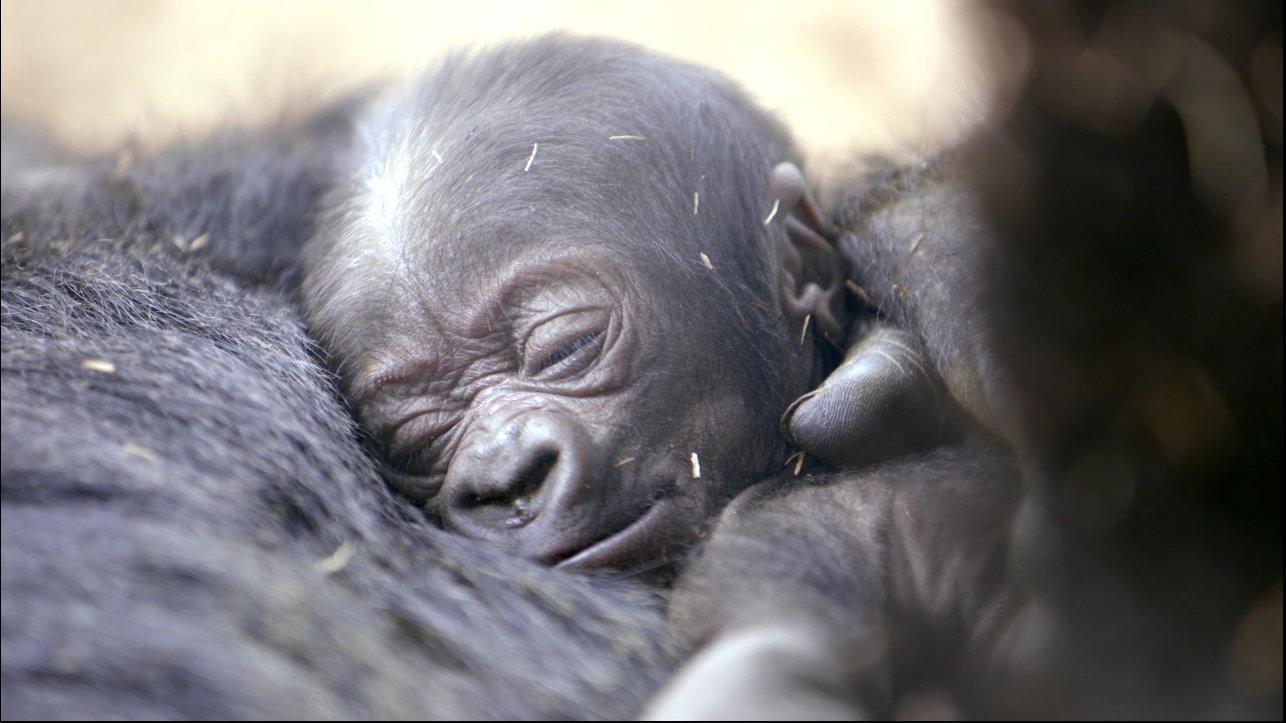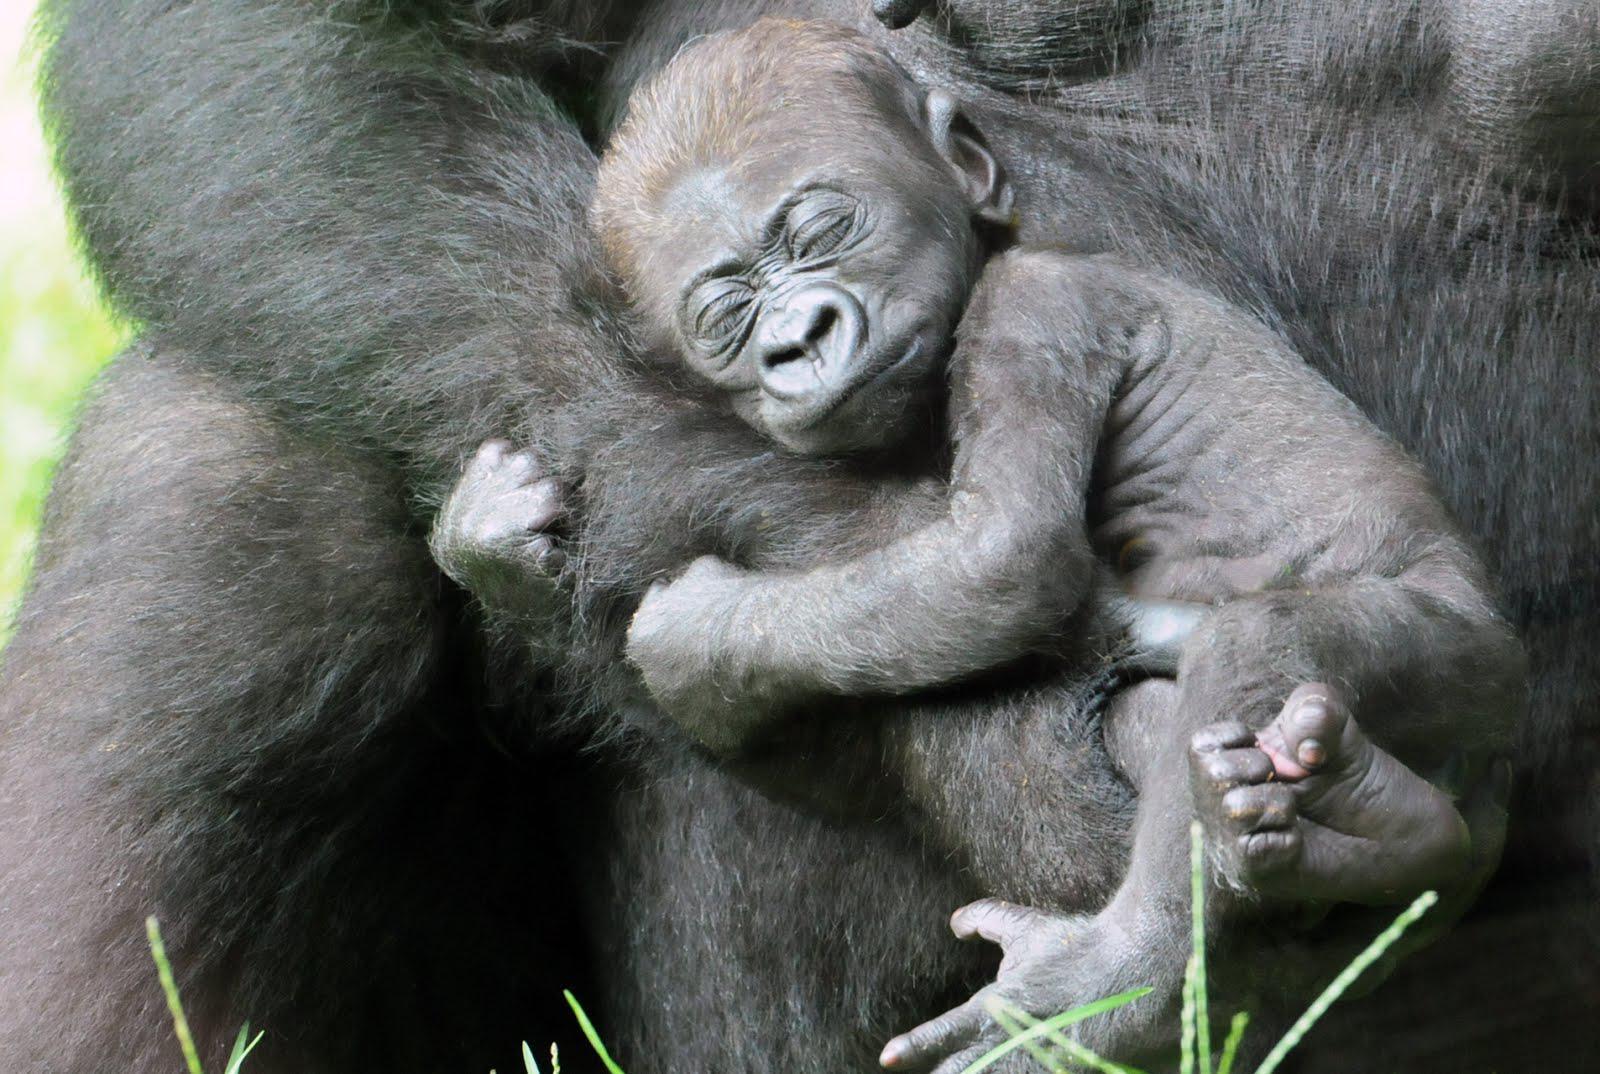The first image is the image on the left, the second image is the image on the right. For the images shown, is this caption "A baby primate lies on an adult in each of the images." true? Answer yes or no. Yes. 